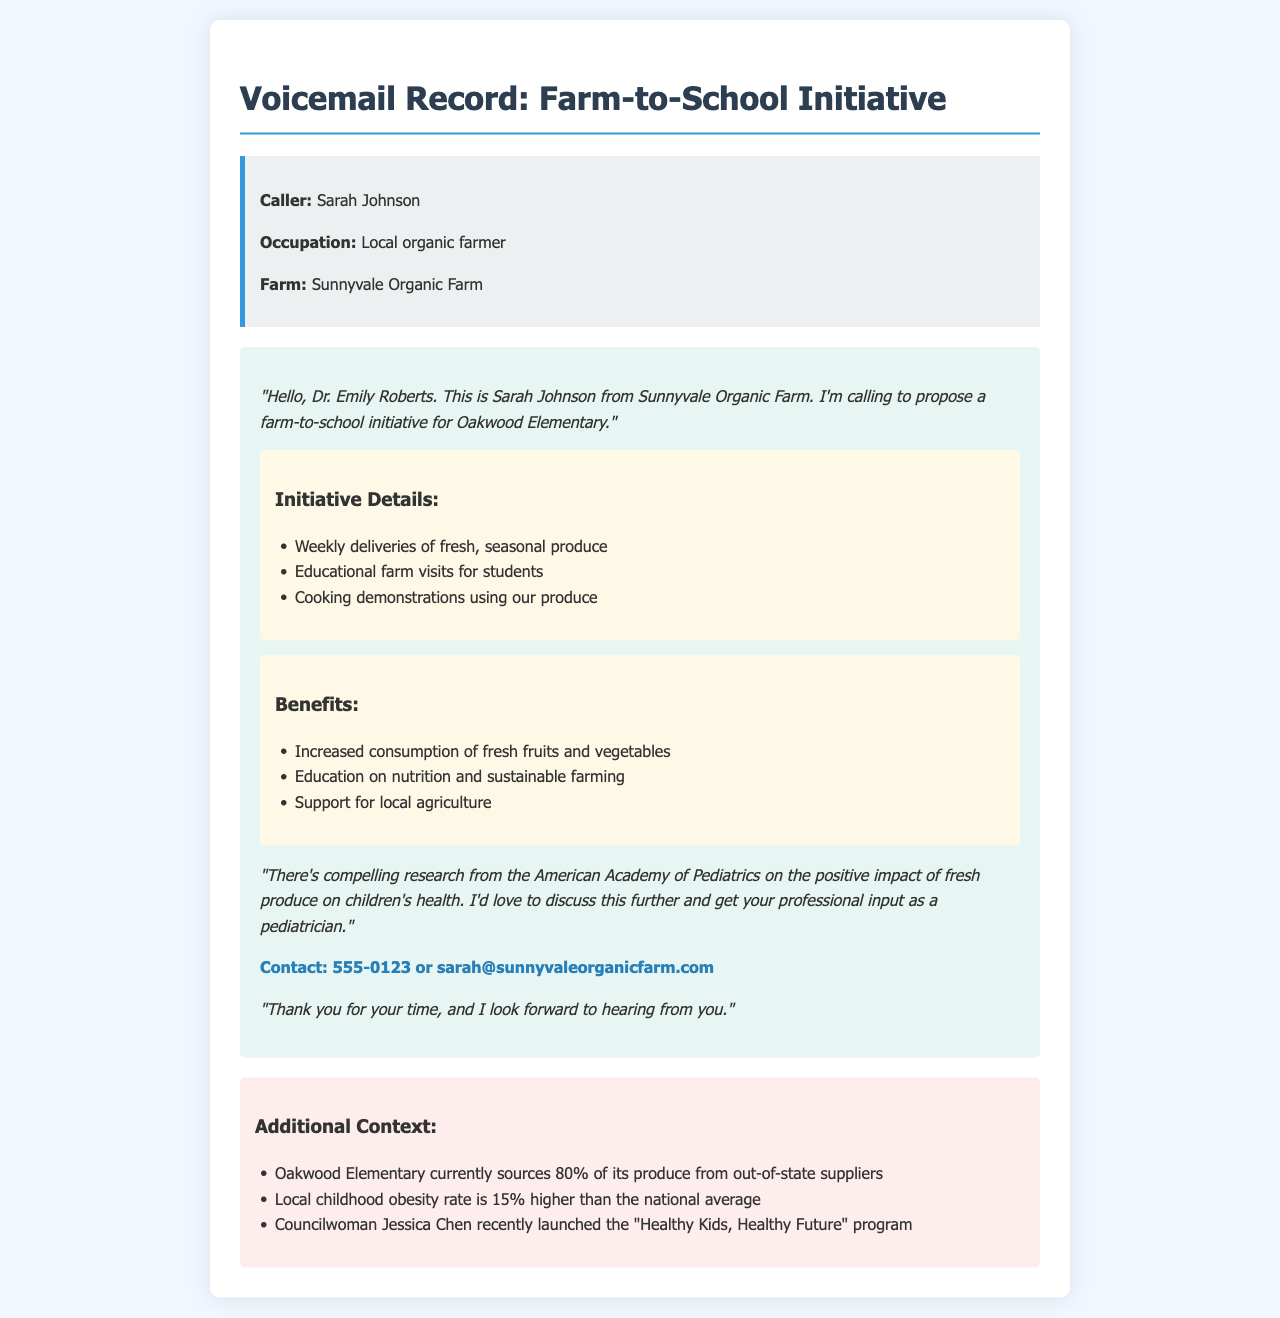What is the caller's name? The caller is introduced at the beginning of the voicemail as Sarah Johnson.
Answer: Sarah Johnson What is the occupation of the caller? The voicemail states that the caller is a local organic farmer.
Answer: Local organic farmer What farm does the caller represent? The voicemail specifies that the caller is from Sunnyvale Organic Farm.
Answer: Sunnyvale Organic Farm What percentage of Oakwood Elementary's produce is sourced from out-of-state suppliers? The document mentions that Oakwood Elementary sources 80% of its produce from out-of-state suppliers.
Answer: 80% What is one benefit of the proposed initiative? The voicemail lists increased consumption of fresh fruits and vegetables as a benefit.
Answer: Increased consumption of fresh fruits and vegetables What is the local childhood obesity rate compared to the national average? The voicemail indicates that the local childhood obesity rate is 15% higher than the national average.
Answer: 15% higher What contact information is provided for the caller? The voicemail includes the contact number and email of Sarah Johnson.
Answer: 555-0123 or sarah@sunnyvaleorganicfarm.com What recent program was launched by Councilwoman Jessica Chen? The document states that Councilwoman Jessica Chen launched the "Healthy Kids, Healthy Future" program.
Answer: "Healthy Kids, Healthy Future" program What type of creative activity is included in the initiative? The voicemail mentions cooking demonstrations using their produce.
Answer: Cooking demonstrations 